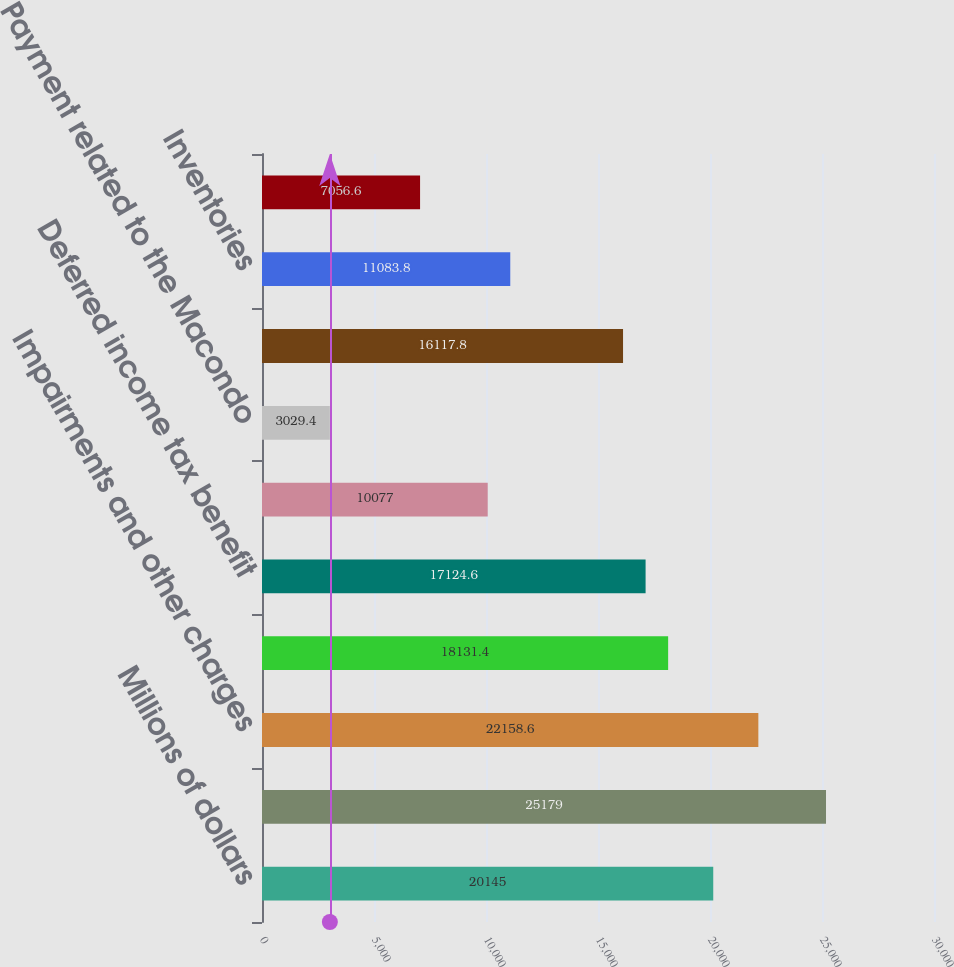<chart> <loc_0><loc_0><loc_500><loc_500><bar_chart><fcel>Millions of dollars<fcel>Net income (loss)<fcel>Impairments and other charges<fcel>Depreciation depletion and<fcel>Deferred income tax benefit<fcel>Cash impact of impairments and<fcel>Payment related to the Macondo<fcel>Receivables<fcel>Inventories<fcel>Accounts payable<nl><fcel>20145<fcel>25179<fcel>22158.6<fcel>18131.4<fcel>17124.6<fcel>10077<fcel>3029.4<fcel>16117.8<fcel>11083.8<fcel>7056.6<nl></chart> 